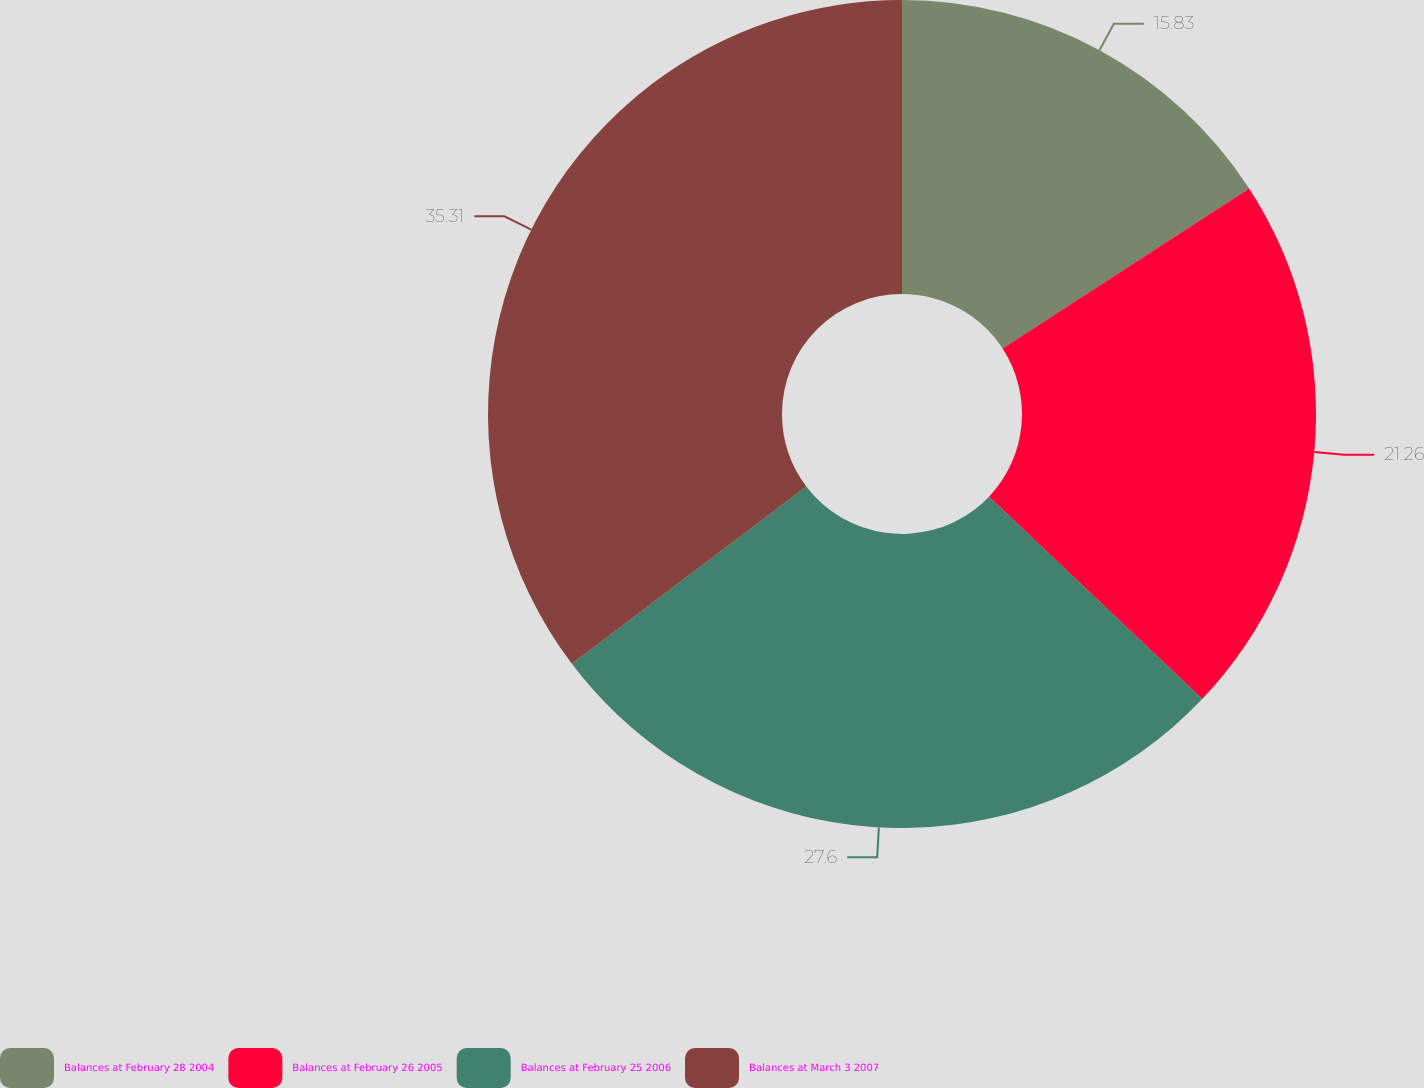Convert chart. <chart><loc_0><loc_0><loc_500><loc_500><pie_chart><fcel>Balances at February 28 2004<fcel>Balances at February 26 2005<fcel>Balances at February 25 2006<fcel>Balances at March 3 2007<nl><fcel>15.83%<fcel>21.26%<fcel>27.6%<fcel>35.31%<nl></chart> 